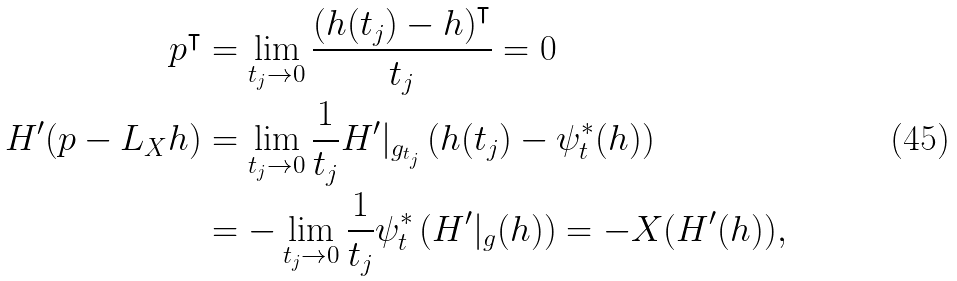<formula> <loc_0><loc_0><loc_500><loc_500>p ^ { \intercal } & = \lim _ { t _ { j } \to 0 } \frac { \left ( h ( t _ { j } ) - h \right ) ^ { \intercal } } { t _ { j } } = 0 \\ H ^ { \prime } ( p - L _ { X } h ) & = \lim _ { t _ { j } \to 0 } \frac { 1 } { t _ { j } } H ^ { \prime } | _ { g _ { t _ { j } } } \left ( h ( t _ { j } ) - \psi ^ { * } _ { t } ( h ) \right ) \\ & = - \lim _ { t _ { j } \to 0 } \frac { 1 } { t _ { j } } \psi _ { t } ^ { * } \left ( H ^ { \prime } | _ { g } ( h ) \right ) = - X ( H ^ { \prime } ( h ) ) ,</formula> 